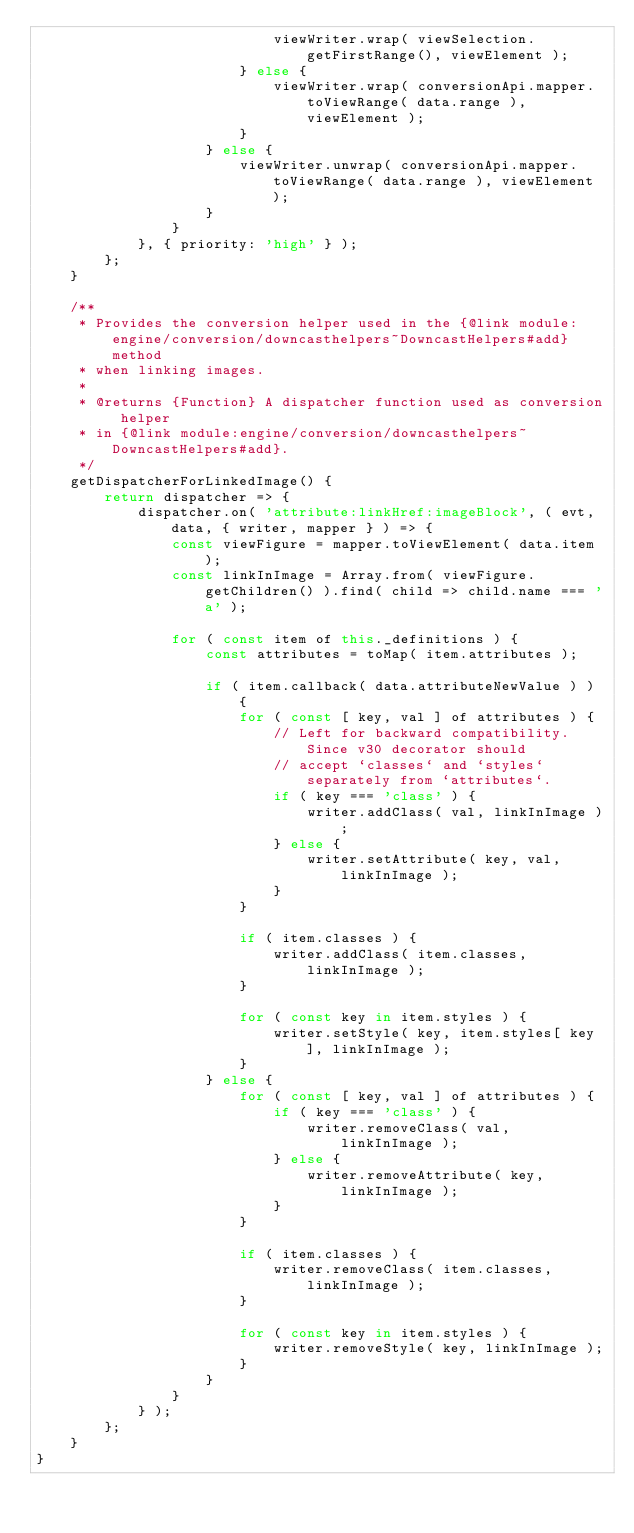Convert code to text. <code><loc_0><loc_0><loc_500><loc_500><_JavaScript_>							viewWriter.wrap( viewSelection.getFirstRange(), viewElement );
						} else {
							viewWriter.wrap( conversionApi.mapper.toViewRange( data.range ), viewElement );
						}
					} else {
						viewWriter.unwrap( conversionApi.mapper.toViewRange( data.range ), viewElement );
					}
				}
			}, { priority: 'high' } );
		};
	}

	/**
	 * Provides the conversion helper used in the {@link module:engine/conversion/downcasthelpers~DowncastHelpers#add} method
	 * when linking images.
	 *
	 * @returns {Function} A dispatcher function used as conversion helper
	 * in {@link module:engine/conversion/downcasthelpers~DowncastHelpers#add}.
	 */
	getDispatcherForLinkedImage() {
		return dispatcher => {
			dispatcher.on( 'attribute:linkHref:imageBlock', ( evt, data, { writer, mapper } ) => {
				const viewFigure = mapper.toViewElement( data.item );
				const linkInImage = Array.from( viewFigure.getChildren() ).find( child => child.name === 'a' );

				for ( const item of this._definitions ) {
					const attributes = toMap( item.attributes );

					if ( item.callback( data.attributeNewValue ) ) {
						for ( const [ key, val ] of attributes ) {
							// Left for backward compatibility. Since v30 decorator should
							// accept `classes` and `styles` separately from `attributes`.
							if ( key === 'class' ) {
								writer.addClass( val, linkInImage );
							} else {
								writer.setAttribute( key, val, linkInImage );
							}
						}

						if ( item.classes ) {
							writer.addClass( item.classes, linkInImage );
						}

						for ( const key in item.styles ) {
							writer.setStyle( key, item.styles[ key ], linkInImage );
						}
					} else {
						for ( const [ key, val ] of attributes ) {
							if ( key === 'class' ) {
								writer.removeClass( val, linkInImage );
							} else {
								writer.removeAttribute( key, linkInImage );
							}
						}

						if ( item.classes ) {
							writer.removeClass( item.classes, linkInImage );
						}

						for ( const key in item.styles ) {
							writer.removeStyle( key, linkInImage );
						}
					}
				}
			} );
		};
	}
}
</code> 